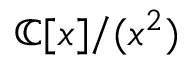<formula> <loc_0><loc_0><loc_500><loc_500>\mathbb { C } [ x ] / ( x ^ { 2 } )</formula> 